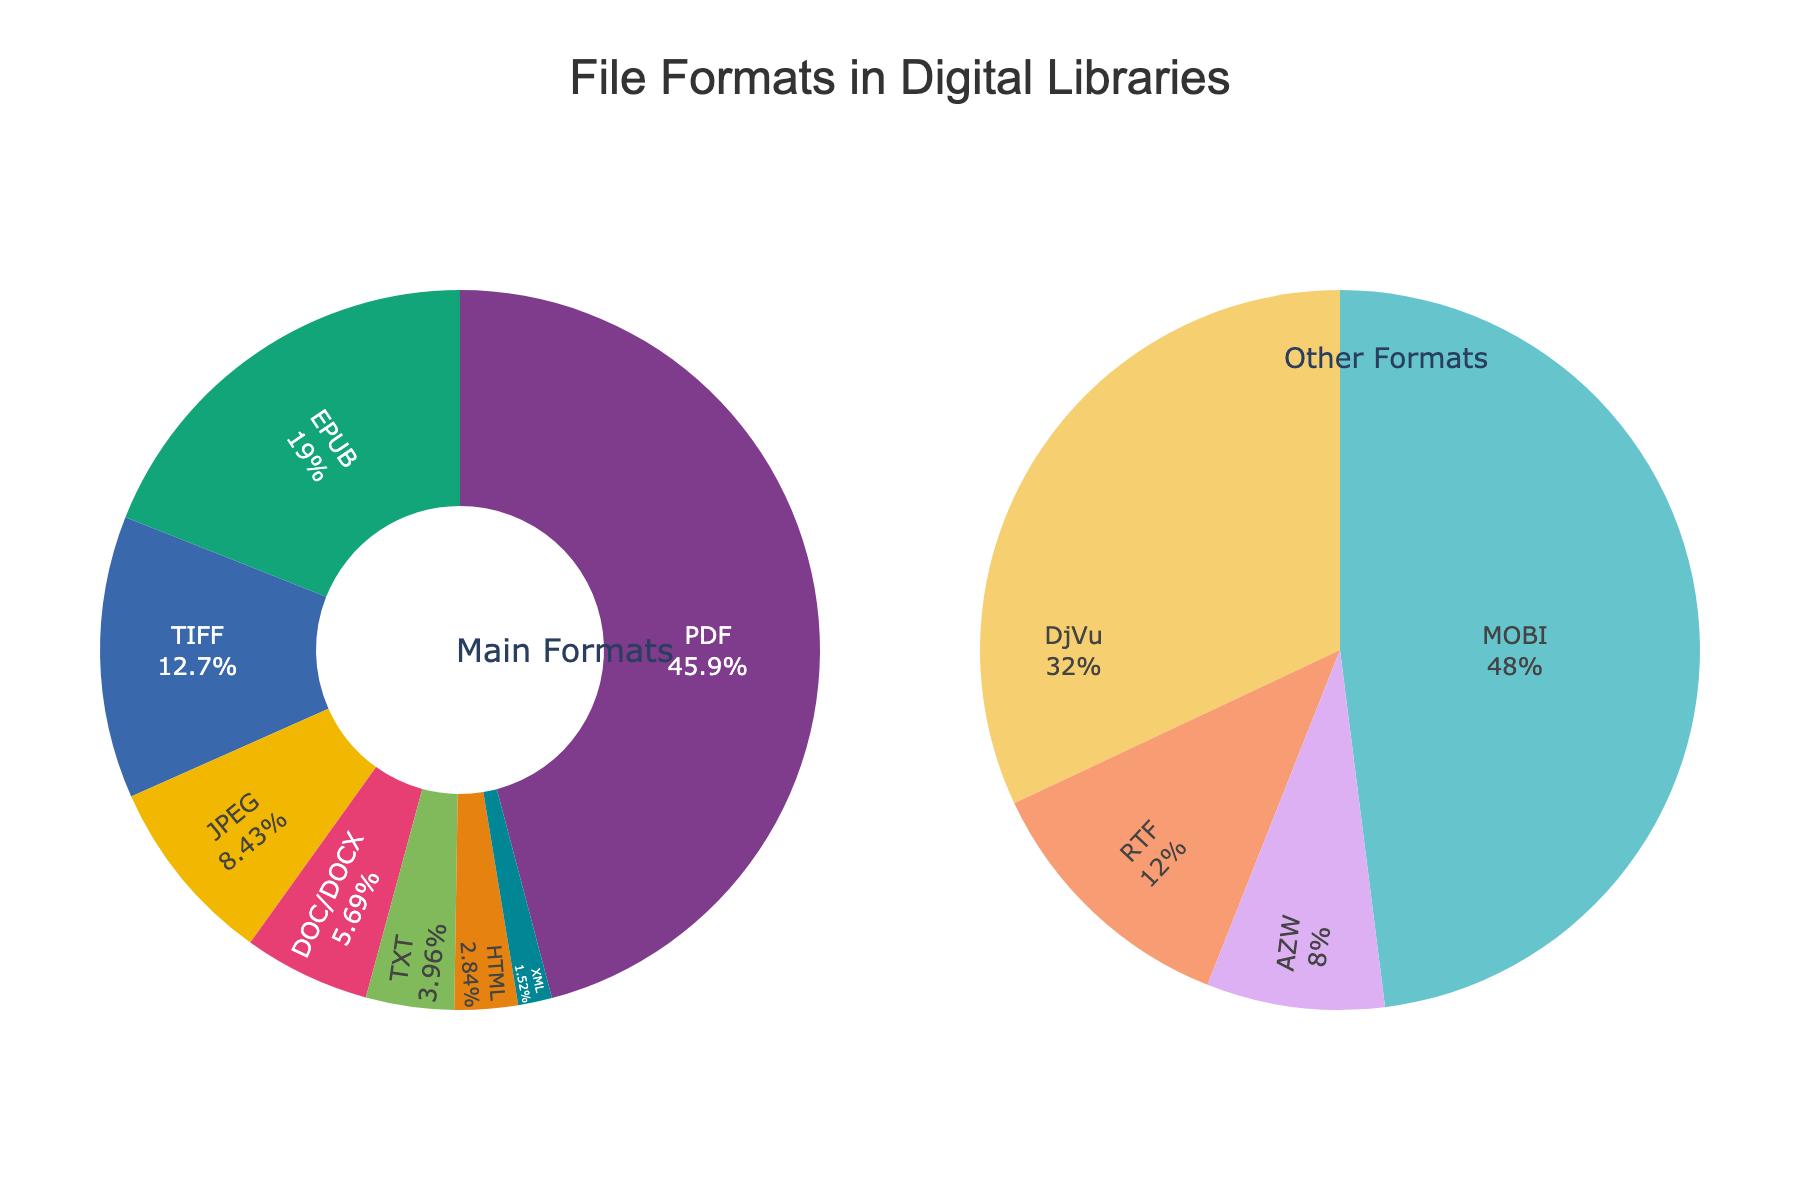What's the most common file format in digital libraries? By looking at the largest segment in the pie chart under 'Main Formats', we can identify the most common file format. The largest segment belongs to the PDF, which occupies 45.2% of the chart.
Answer: PDF Which file formats make up over 50% of the total distribution when combined? First, observe the percentages of the individual file formats in the 'Main Formats' pie chart. Combining PDF (45.2%) and EPUB (18.7%) yields 63.9%, which is over 50%.
Answer: PDF and EPUB What percentage of the formats constitute 'Other Formats'? To find this, add up the percentages of formats in the 'Other Formats' pie-chart. Summing XML (1.5%), MOBI (1.2%), DjVu (0.8%), RTF (0.3%), and AZW (0.2%) results in 4%.
Answer: 4% Is the percentage of JPEG greater than the combined percentage of DOC/DOCX and TXT? Compare the percentage for JPEG (8.3%) with the combined percentage for DOC/DOCX (5.6%) and TXT (3.9%). The sum of DOC/DOCX and TXT is 9.5%, which is greater than 8.3%.
Answer: No Which format has the smallest percentage representation in the 'Main Formats' pie chart? By examining the 'Main Formats' pie chart, identify the smallest segment. The smallest segment there belongs to HTML, with 2.8%.
Answer: HTML How does the percentage of TIFF compare to the combined percentage of XML and MOBI? Compare the TIFF percentage (12.5%) with the sum of XML (1.5%) and MOBI (1.2%), which results in 2.7%. Since 12.5% is greater than 2.7%, TIFF has a larger percentage.
Answer: TIFF has a larger percentage What is the aggregated percentage for 'Main Formats'? Add up the percentages of the formats in the 'Main Formats' pie chart: PDF (45.2%), EPUB (18.7%), TIFF (12.5%), JPEG (8.3%), DOC/DOCX (5.6%), TXT (3.9%), HTML (2.8%). The total is 97%.
Answer: 97% What is the contrast in percentages between the most and least common format within the 'Main Formats'? Subtract the percentage of the least common format (HTML, 2.8%) from the most common format (PDF, 45.2%). The result is 45.2% - 2.8% = 42.4%.
Answer: 42.4% 